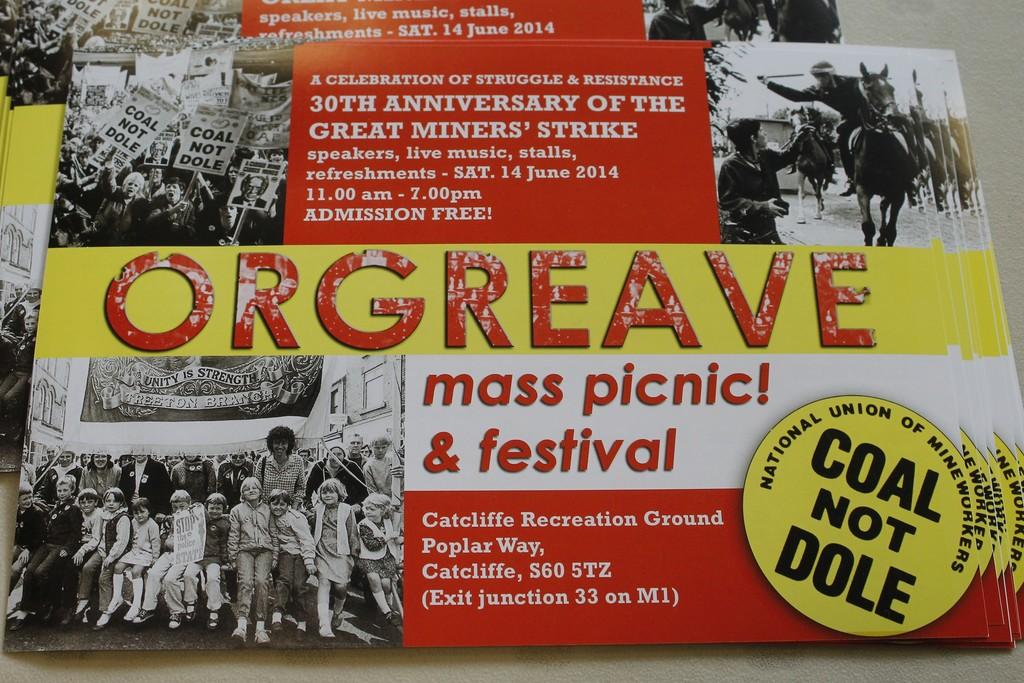What is the name of the festival?
Your answer should be very brief. Orgreave. What is in the circle in the bottom right?
Provide a succinct answer. Coal not dole. 